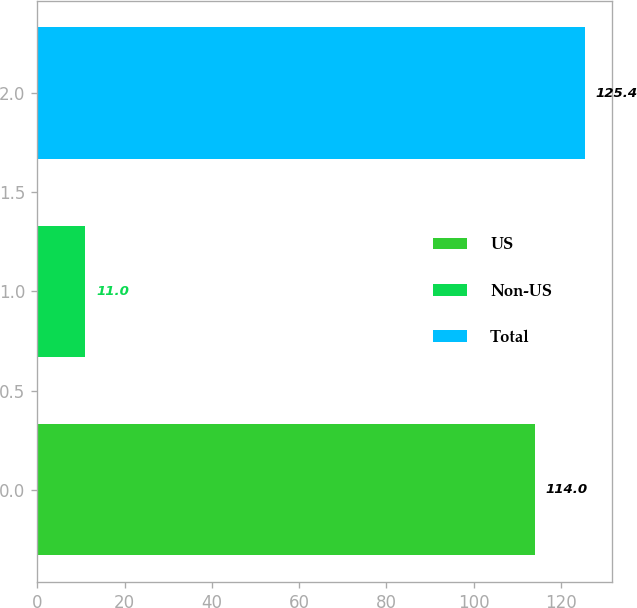Convert chart. <chart><loc_0><loc_0><loc_500><loc_500><bar_chart><fcel>US<fcel>Non-US<fcel>Total<nl><fcel>114<fcel>11<fcel>125.4<nl></chart> 